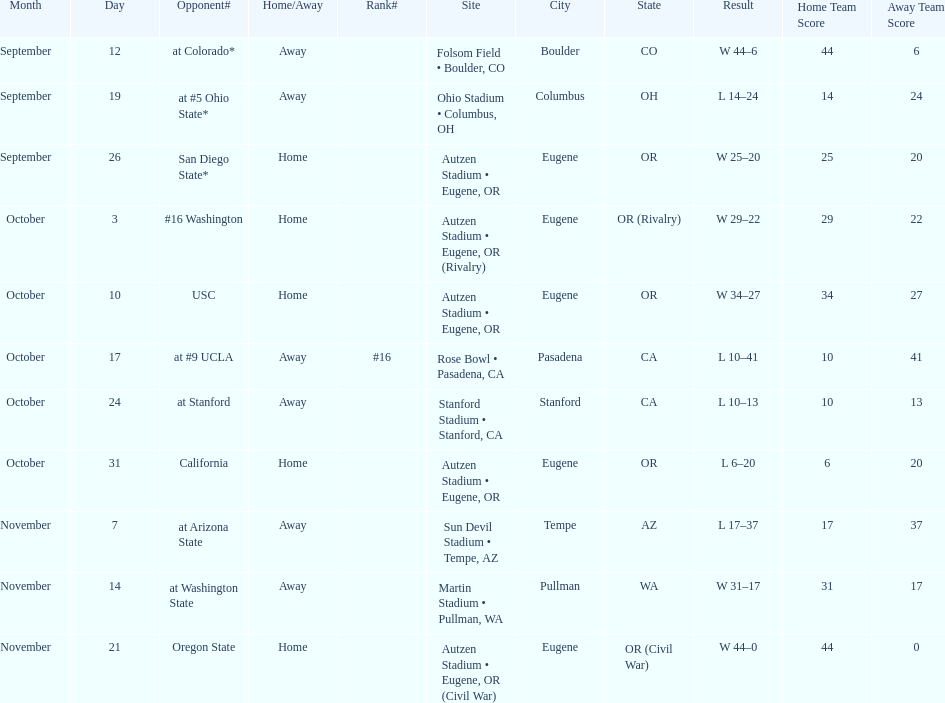How many wins are listed for the season? 6. 